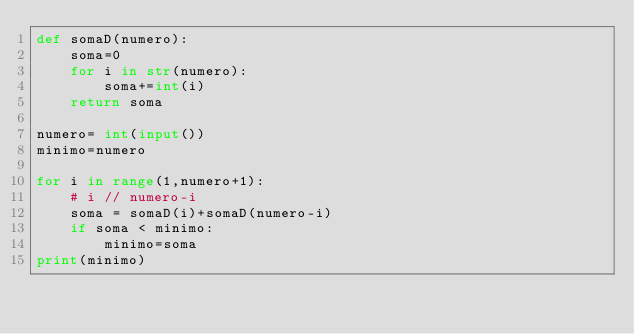<code> <loc_0><loc_0><loc_500><loc_500><_Python_>def somaD(numero):
    soma=0
    for i in str(numero):
        soma+=int(i)
    return soma

numero= int(input())
minimo=numero

for i in range(1,numero+1):
    # i // numero-i
    soma = somaD(i)+somaD(numero-i)
    if soma < minimo:
        minimo=soma
print(minimo)</code> 